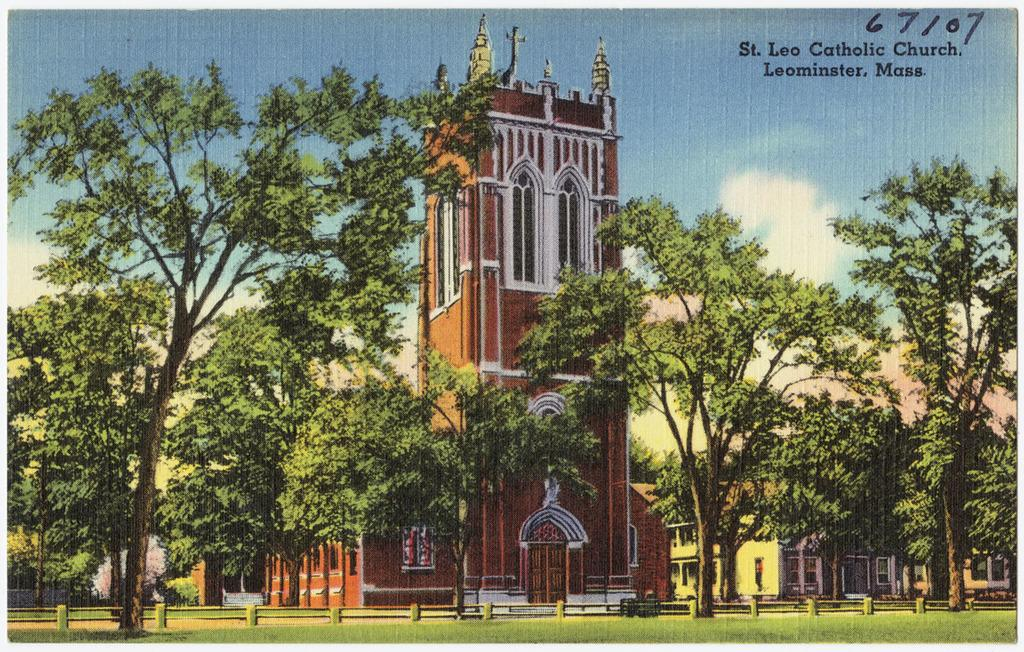<image>
Relay a brief, clear account of the picture shown. A drawing of a church is labeled St. Leo Catholic Church in the upper right corner. 